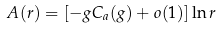Convert formula to latex. <formula><loc_0><loc_0><loc_500><loc_500>A ( r ) = [ - g C _ { a } ( g ) + o ( 1 ) ] \ln r</formula> 